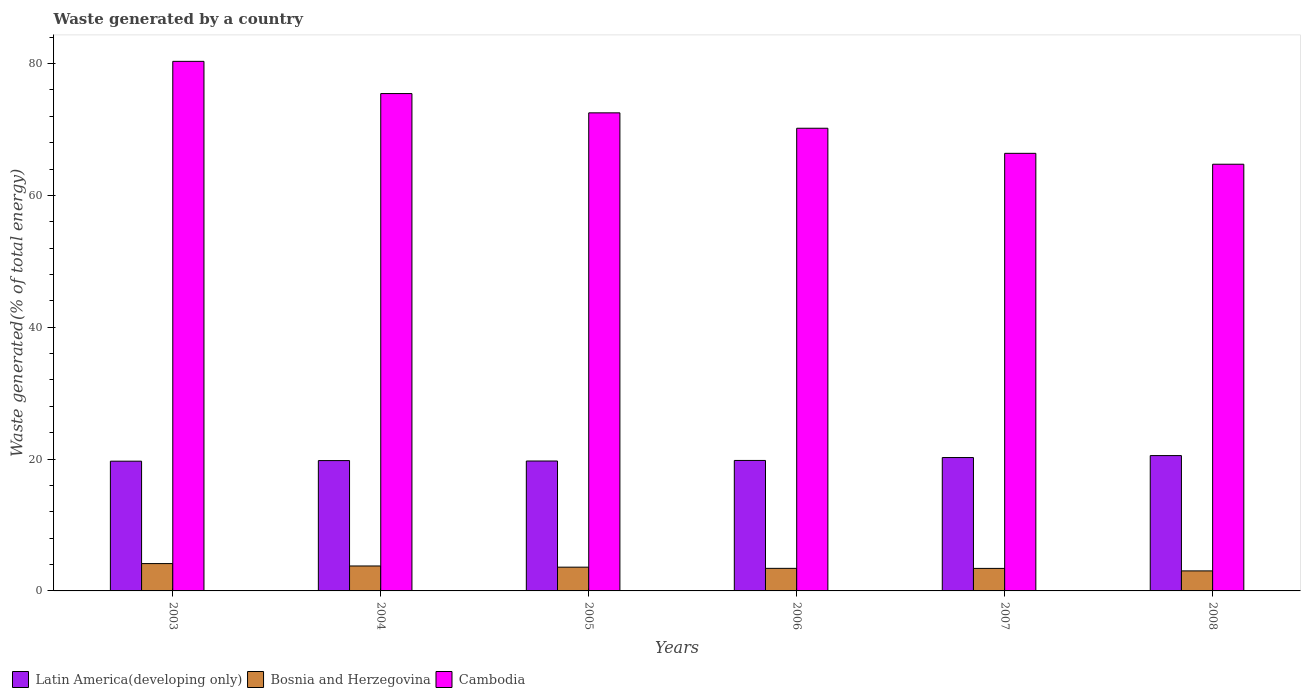How many different coloured bars are there?
Your response must be concise. 3. How many groups of bars are there?
Ensure brevity in your answer.  6. How many bars are there on the 6th tick from the left?
Provide a succinct answer. 3. How many bars are there on the 2nd tick from the right?
Your answer should be compact. 3. In how many cases, is the number of bars for a given year not equal to the number of legend labels?
Keep it short and to the point. 0. What is the total waste generated in Cambodia in 2007?
Offer a terse response. 66.38. Across all years, what is the maximum total waste generated in Cambodia?
Your response must be concise. 80.34. Across all years, what is the minimum total waste generated in Bosnia and Herzegovina?
Make the answer very short. 3.04. In which year was the total waste generated in Latin America(developing only) minimum?
Ensure brevity in your answer.  2003. What is the total total waste generated in Cambodia in the graph?
Your answer should be very brief. 429.62. What is the difference between the total waste generated in Bosnia and Herzegovina in 2004 and that in 2005?
Keep it short and to the point. 0.18. What is the difference between the total waste generated in Latin America(developing only) in 2005 and the total waste generated in Bosnia and Herzegovina in 2003?
Make the answer very short. 15.56. What is the average total waste generated in Cambodia per year?
Your answer should be compact. 71.6. In the year 2004, what is the difference between the total waste generated in Bosnia and Herzegovina and total waste generated in Cambodia?
Offer a very short reply. -71.67. What is the ratio of the total waste generated in Latin America(developing only) in 2004 to that in 2005?
Ensure brevity in your answer.  1. What is the difference between the highest and the second highest total waste generated in Bosnia and Herzegovina?
Offer a very short reply. 0.36. What is the difference between the highest and the lowest total waste generated in Bosnia and Herzegovina?
Give a very brief answer. 1.11. In how many years, is the total waste generated in Bosnia and Herzegovina greater than the average total waste generated in Bosnia and Herzegovina taken over all years?
Make the answer very short. 3. Is the sum of the total waste generated in Cambodia in 2007 and 2008 greater than the maximum total waste generated in Latin America(developing only) across all years?
Ensure brevity in your answer.  Yes. What does the 1st bar from the left in 2007 represents?
Offer a terse response. Latin America(developing only). What does the 1st bar from the right in 2003 represents?
Provide a short and direct response. Cambodia. Are all the bars in the graph horizontal?
Your answer should be compact. No. What is the difference between two consecutive major ticks on the Y-axis?
Provide a succinct answer. 20. Are the values on the major ticks of Y-axis written in scientific E-notation?
Keep it short and to the point. No. How many legend labels are there?
Your answer should be compact. 3. What is the title of the graph?
Provide a succinct answer. Waste generated by a country. What is the label or title of the Y-axis?
Give a very brief answer. Waste generated(% of total energy). What is the Waste generated(% of total energy) of Latin America(developing only) in 2003?
Provide a short and direct response. 19.68. What is the Waste generated(% of total energy) in Bosnia and Herzegovina in 2003?
Provide a short and direct response. 4.15. What is the Waste generated(% of total energy) of Cambodia in 2003?
Make the answer very short. 80.34. What is the Waste generated(% of total energy) of Latin America(developing only) in 2004?
Ensure brevity in your answer.  19.77. What is the Waste generated(% of total energy) in Bosnia and Herzegovina in 2004?
Offer a terse response. 3.79. What is the Waste generated(% of total energy) in Cambodia in 2004?
Ensure brevity in your answer.  75.45. What is the Waste generated(% of total energy) of Latin America(developing only) in 2005?
Offer a very short reply. 19.71. What is the Waste generated(% of total energy) of Bosnia and Herzegovina in 2005?
Provide a short and direct response. 3.61. What is the Waste generated(% of total energy) of Cambodia in 2005?
Provide a succinct answer. 72.53. What is the Waste generated(% of total energy) in Latin America(developing only) in 2006?
Offer a terse response. 19.79. What is the Waste generated(% of total energy) in Bosnia and Herzegovina in 2006?
Provide a succinct answer. 3.42. What is the Waste generated(% of total energy) in Cambodia in 2006?
Give a very brief answer. 70.19. What is the Waste generated(% of total energy) of Latin America(developing only) in 2007?
Your answer should be very brief. 20.23. What is the Waste generated(% of total energy) of Bosnia and Herzegovina in 2007?
Your answer should be compact. 3.42. What is the Waste generated(% of total energy) in Cambodia in 2007?
Your response must be concise. 66.38. What is the Waste generated(% of total energy) in Latin America(developing only) in 2008?
Your answer should be compact. 20.53. What is the Waste generated(% of total energy) in Bosnia and Herzegovina in 2008?
Your answer should be very brief. 3.04. What is the Waste generated(% of total energy) of Cambodia in 2008?
Your answer should be very brief. 64.73. Across all years, what is the maximum Waste generated(% of total energy) in Latin America(developing only)?
Offer a very short reply. 20.53. Across all years, what is the maximum Waste generated(% of total energy) in Bosnia and Herzegovina?
Offer a terse response. 4.15. Across all years, what is the maximum Waste generated(% of total energy) in Cambodia?
Ensure brevity in your answer.  80.34. Across all years, what is the minimum Waste generated(% of total energy) of Latin America(developing only)?
Make the answer very short. 19.68. Across all years, what is the minimum Waste generated(% of total energy) of Bosnia and Herzegovina?
Make the answer very short. 3.04. Across all years, what is the minimum Waste generated(% of total energy) of Cambodia?
Give a very brief answer. 64.73. What is the total Waste generated(% of total energy) of Latin America(developing only) in the graph?
Make the answer very short. 119.72. What is the total Waste generated(% of total energy) in Bosnia and Herzegovina in the graph?
Keep it short and to the point. 21.42. What is the total Waste generated(% of total energy) of Cambodia in the graph?
Keep it short and to the point. 429.62. What is the difference between the Waste generated(% of total energy) in Latin America(developing only) in 2003 and that in 2004?
Make the answer very short. -0.09. What is the difference between the Waste generated(% of total energy) in Bosnia and Herzegovina in 2003 and that in 2004?
Your answer should be compact. 0.36. What is the difference between the Waste generated(% of total energy) of Cambodia in 2003 and that in 2004?
Provide a succinct answer. 4.89. What is the difference between the Waste generated(% of total energy) in Latin America(developing only) in 2003 and that in 2005?
Provide a succinct answer. -0.03. What is the difference between the Waste generated(% of total energy) of Bosnia and Herzegovina in 2003 and that in 2005?
Your answer should be very brief. 0.54. What is the difference between the Waste generated(% of total energy) of Cambodia in 2003 and that in 2005?
Provide a succinct answer. 7.81. What is the difference between the Waste generated(% of total energy) in Latin America(developing only) in 2003 and that in 2006?
Provide a succinct answer. -0.11. What is the difference between the Waste generated(% of total energy) in Bosnia and Herzegovina in 2003 and that in 2006?
Offer a very short reply. 0.72. What is the difference between the Waste generated(% of total energy) of Cambodia in 2003 and that in 2006?
Ensure brevity in your answer.  10.15. What is the difference between the Waste generated(% of total energy) in Latin America(developing only) in 2003 and that in 2007?
Provide a short and direct response. -0.55. What is the difference between the Waste generated(% of total energy) in Bosnia and Herzegovina in 2003 and that in 2007?
Your answer should be very brief. 0.73. What is the difference between the Waste generated(% of total energy) of Cambodia in 2003 and that in 2007?
Provide a succinct answer. 13.95. What is the difference between the Waste generated(% of total energy) in Latin America(developing only) in 2003 and that in 2008?
Offer a very short reply. -0.85. What is the difference between the Waste generated(% of total energy) in Bosnia and Herzegovina in 2003 and that in 2008?
Your answer should be compact. 1.11. What is the difference between the Waste generated(% of total energy) of Cambodia in 2003 and that in 2008?
Ensure brevity in your answer.  15.61. What is the difference between the Waste generated(% of total energy) of Latin America(developing only) in 2004 and that in 2005?
Keep it short and to the point. 0.06. What is the difference between the Waste generated(% of total energy) of Bosnia and Herzegovina in 2004 and that in 2005?
Keep it short and to the point. 0.18. What is the difference between the Waste generated(% of total energy) of Cambodia in 2004 and that in 2005?
Offer a terse response. 2.93. What is the difference between the Waste generated(% of total energy) in Latin America(developing only) in 2004 and that in 2006?
Provide a short and direct response. -0.02. What is the difference between the Waste generated(% of total energy) in Bosnia and Herzegovina in 2004 and that in 2006?
Offer a very short reply. 0.36. What is the difference between the Waste generated(% of total energy) in Cambodia in 2004 and that in 2006?
Your answer should be very brief. 5.26. What is the difference between the Waste generated(% of total energy) in Latin America(developing only) in 2004 and that in 2007?
Make the answer very short. -0.46. What is the difference between the Waste generated(% of total energy) of Bosnia and Herzegovina in 2004 and that in 2007?
Your answer should be compact. 0.37. What is the difference between the Waste generated(% of total energy) of Cambodia in 2004 and that in 2007?
Offer a very short reply. 9.07. What is the difference between the Waste generated(% of total energy) of Latin America(developing only) in 2004 and that in 2008?
Give a very brief answer. -0.76. What is the difference between the Waste generated(% of total energy) of Bosnia and Herzegovina in 2004 and that in 2008?
Provide a short and direct response. 0.75. What is the difference between the Waste generated(% of total energy) of Cambodia in 2004 and that in 2008?
Offer a terse response. 10.72. What is the difference between the Waste generated(% of total energy) in Latin America(developing only) in 2005 and that in 2006?
Your response must be concise. -0.09. What is the difference between the Waste generated(% of total energy) of Bosnia and Herzegovina in 2005 and that in 2006?
Your answer should be very brief. 0.18. What is the difference between the Waste generated(% of total energy) in Cambodia in 2005 and that in 2006?
Give a very brief answer. 2.33. What is the difference between the Waste generated(% of total energy) in Latin America(developing only) in 2005 and that in 2007?
Provide a succinct answer. -0.53. What is the difference between the Waste generated(% of total energy) of Bosnia and Herzegovina in 2005 and that in 2007?
Give a very brief answer. 0.19. What is the difference between the Waste generated(% of total energy) of Cambodia in 2005 and that in 2007?
Your answer should be compact. 6.14. What is the difference between the Waste generated(% of total energy) in Latin America(developing only) in 2005 and that in 2008?
Your response must be concise. -0.82. What is the difference between the Waste generated(% of total energy) of Bosnia and Herzegovina in 2005 and that in 2008?
Your response must be concise. 0.57. What is the difference between the Waste generated(% of total energy) of Cambodia in 2005 and that in 2008?
Offer a terse response. 7.79. What is the difference between the Waste generated(% of total energy) of Latin America(developing only) in 2006 and that in 2007?
Your response must be concise. -0.44. What is the difference between the Waste generated(% of total energy) of Bosnia and Herzegovina in 2006 and that in 2007?
Give a very brief answer. 0.01. What is the difference between the Waste generated(% of total energy) in Cambodia in 2006 and that in 2007?
Offer a very short reply. 3.81. What is the difference between the Waste generated(% of total energy) in Latin America(developing only) in 2006 and that in 2008?
Your answer should be very brief. -0.74. What is the difference between the Waste generated(% of total energy) in Bosnia and Herzegovina in 2006 and that in 2008?
Your response must be concise. 0.39. What is the difference between the Waste generated(% of total energy) in Cambodia in 2006 and that in 2008?
Your answer should be compact. 5.46. What is the difference between the Waste generated(% of total energy) in Latin America(developing only) in 2007 and that in 2008?
Offer a terse response. -0.3. What is the difference between the Waste generated(% of total energy) of Bosnia and Herzegovina in 2007 and that in 2008?
Ensure brevity in your answer.  0.38. What is the difference between the Waste generated(% of total energy) in Cambodia in 2007 and that in 2008?
Keep it short and to the point. 1.65. What is the difference between the Waste generated(% of total energy) in Latin America(developing only) in 2003 and the Waste generated(% of total energy) in Bosnia and Herzegovina in 2004?
Your answer should be compact. 15.9. What is the difference between the Waste generated(% of total energy) of Latin America(developing only) in 2003 and the Waste generated(% of total energy) of Cambodia in 2004?
Keep it short and to the point. -55.77. What is the difference between the Waste generated(% of total energy) in Bosnia and Herzegovina in 2003 and the Waste generated(% of total energy) in Cambodia in 2004?
Offer a terse response. -71.3. What is the difference between the Waste generated(% of total energy) of Latin America(developing only) in 2003 and the Waste generated(% of total energy) of Bosnia and Herzegovina in 2005?
Provide a succinct answer. 16.08. What is the difference between the Waste generated(% of total energy) of Latin America(developing only) in 2003 and the Waste generated(% of total energy) of Cambodia in 2005?
Your answer should be compact. -52.84. What is the difference between the Waste generated(% of total energy) of Bosnia and Herzegovina in 2003 and the Waste generated(% of total energy) of Cambodia in 2005?
Make the answer very short. -68.38. What is the difference between the Waste generated(% of total energy) of Latin America(developing only) in 2003 and the Waste generated(% of total energy) of Bosnia and Herzegovina in 2006?
Offer a terse response. 16.26. What is the difference between the Waste generated(% of total energy) in Latin America(developing only) in 2003 and the Waste generated(% of total energy) in Cambodia in 2006?
Offer a terse response. -50.51. What is the difference between the Waste generated(% of total energy) in Bosnia and Herzegovina in 2003 and the Waste generated(% of total energy) in Cambodia in 2006?
Give a very brief answer. -66.04. What is the difference between the Waste generated(% of total energy) of Latin America(developing only) in 2003 and the Waste generated(% of total energy) of Bosnia and Herzegovina in 2007?
Give a very brief answer. 16.27. What is the difference between the Waste generated(% of total energy) in Latin America(developing only) in 2003 and the Waste generated(% of total energy) in Cambodia in 2007?
Your answer should be compact. -46.7. What is the difference between the Waste generated(% of total energy) of Bosnia and Herzegovina in 2003 and the Waste generated(% of total energy) of Cambodia in 2007?
Your answer should be compact. -62.24. What is the difference between the Waste generated(% of total energy) in Latin America(developing only) in 2003 and the Waste generated(% of total energy) in Bosnia and Herzegovina in 2008?
Make the answer very short. 16.64. What is the difference between the Waste generated(% of total energy) of Latin America(developing only) in 2003 and the Waste generated(% of total energy) of Cambodia in 2008?
Your answer should be very brief. -45.05. What is the difference between the Waste generated(% of total energy) in Bosnia and Herzegovina in 2003 and the Waste generated(% of total energy) in Cambodia in 2008?
Provide a succinct answer. -60.58. What is the difference between the Waste generated(% of total energy) of Latin America(developing only) in 2004 and the Waste generated(% of total energy) of Bosnia and Herzegovina in 2005?
Provide a short and direct response. 16.17. What is the difference between the Waste generated(% of total energy) of Latin America(developing only) in 2004 and the Waste generated(% of total energy) of Cambodia in 2005?
Your answer should be compact. -52.75. What is the difference between the Waste generated(% of total energy) in Bosnia and Herzegovina in 2004 and the Waste generated(% of total energy) in Cambodia in 2005?
Offer a terse response. -68.74. What is the difference between the Waste generated(% of total energy) in Latin America(developing only) in 2004 and the Waste generated(% of total energy) in Bosnia and Herzegovina in 2006?
Provide a succinct answer. 16.35. What is the difference between the Waste generated(% of total energy) of Latin America(developing only) in 2004 and the Waste generated(% of total energy) of Cambodia in 2006?
Provide a succinct answer. -50.42. What is the difference between the Waste generated(% of total energy) in Bosnia and Herzegovina in 2004 and the Waste generated(% of total energy) in Cambodia in 2006?
Offer a very short reply. -66.41. What is the difference between the Waste generated(% of total energy) in Latin America(developing only) in 2004 and the Waste generated(% of total energy) in Bosnia and Herzegovina in 2007?
Offer a terse response. 16.36. What is the difference between the Waste generated(% of total energy) of Latin America(developing only) in 2004 and the Waste generated(% of total energy) of Cambodia in 2007?
Your response must be concise. -46.61. What is the difference between the Waste generated(% of total energy) in Bosnia and Herzegovina in 2004 and the Waste generated(% of total energy) in Cambodia in 2007?
Provide a succinct answer. -62.6. What is the difference between the Waste generated(% of total energy) of Latin America(developing only) in 2004 and the Waste generated(% of total energy) of Bosnia and Herzegovina in 2008?
Your answer should be compact. 16.73. What is the difference between the Waste generated(% of total energy) in Latin America(developing only) in 2004 and the Waste generated(% of total energy) in Cambodia in 2008?
Your answer should be compact. -44.96. What is the difference between the Waste generated(% of total energy) in Bosnia and Herzegovina in 2004 and the Waste generated(% of total energy) in Cambodia in 2008?
Make the answer very short. -60.95. What is the difference between the Waste generated(% of total energy) of Latin America(developing only) in 2005 and the Waste generated(% of total energy) of Bosnia and Herzegovina in 2006?
Offer a very short reply. 16.28. What is the difference between the Waste generated(% of total energy) of Latin America(developing only) in 2005 and the Waste generated(% of total energy) of Cambodia in 2006?
Offer a terse response. -50.48. What is the difference between the Waste generated(% of total energy) in Bosnia and Herzegovina in 2005 and the Waste generated(% of total energy) in Cambodia in 2006?
Your answer should be compact. -66.59. What is the difference between the Waste generated(% of total energy) of Latin America(developing only) in 2005 and the Waste generated(% of total energy) of Bosnia and Herzegovina in 2007?
Keep it short and to the point. 16.29. What is the difference between the Waste generated(% of total energy) of Latin America(developing only) in 2005 and the Waste generated(% of total energy) of Cambodia in 2007?
Make the answer very short. -46.68. What is the difference between the Waste generated(% of total energy) of Bosnia and Herzegovina in 2005 and the Waste generated(% of total energy) of Cambodia in 2007?
Your answer should be compact. -62.78. What is the difference between the Waste generated(% of total energy) in Latin America(developing only) in 2005 and the Waste generated(% of total energy) in Bosnia and Herzegovina in 2008?
Provide a succinct answer. 16.67. What is the difference between the Waste generated(% of total energy) of Latin America(developing only) in 2005 and the Waste generated(% of total energy) of Cambodia in 2008?
Offer a very short reply. -45.02. What is the difference between the Waste generated(% of total energy) in Bosnia and Herzegovina in 2005 and the Waste generated(% of total energy) in Cambodia in 2008?
Offer a terse response. -61.13. What is the difference between the Waste generated(% of total energy) of Latin America(developing only) in 2006 and the Waste generated(% of total energy) of Bosnia and Herzegovina in 2007?
Provide a succinct answer. 16.38. What is the difference between the Waste generated(% of total energy) of Latin America(developing only) in 2006 and the Waste generated(% of total energy) of Cambodia in 2007?
Your answer should be very brief. -46.59. What is the difference between the Waste generated(% of total energy) of Bosnia and Herzegovina in 2006 and the Waste generated(% of total energy) of Cambodia in 2007?
Make the answer very short. -62.96. What is the difference between the Waste generated(% of total energy) of Latin America(developing only) in 2006 and the Waste generated(% of total energy) of Bosnia and Herzegovina in 2008?
Give a very brief answer. 16.76. What is the difference between the Waste generated(% of total energy) of Latin America(developing only) in 2006 and the Waste generated(% of total energy) of Cambodia in 2008?
Offer a terse response. -44.94. What is the difference between the Waste generated(% of total energy) in Bosnia and Herzegovina in 2006 and the Waste generated(% of total energy) in Cambodia in 2008?
Provide a succinct answer. -61.31. What is the difference between the Waste generated(% of total energy) in Latin America(developing only) in 2007 and the Waste generated(% of total energy) in Bosnia and Herzegovina in 2008?
Your answer should be very brief. 17.2. What is the difference between the Waste generated(% of total energy) of Latin America(developing only) in 2007 and the Waste generated(% of total energy) of Cambodia in 2008?
Your answer should be very brief. -44.5. What is the difference between the Waste generated(% of total energy) of Bosnia and Herzegovina in 2007 and the Waste generated(% of total energy) of Cambodia in 2008?
Your answer should be very brief. -61.32. What is the average Waste generated(% of total energy) in Latin America(developing only) per year?
Give a very brief answer. 19.95. What is the average Waste generated(% of total energy) of Bosnia and Herzegovina per year?
Your response must be concise. 3.57. What is the average Waste generated(% of total energy) of Cambodia per year?
Give a very brief answer. 71.6. In the year 2003, what is the difference between the Waste generated(% of total energy) in Latin America(developing only) and Waste generated(% of total energy) in Bosnia and Herzegovina?
Keep it short and to the point. 15.53. In the year 2003, what is the difference between the Waste generated(% of total energy) of Latin America(developing only) and Waste generated(% of total energy) of Cambodia?
Give a very brief answer. -60.66. In the year 2003, what is the difference between the Waste generated(% of total energy) in Bosnia and Herzegovina and Waste generated(% of total energy) in Cambodia?
Make the answer very short. -76.19. In the year 2004, what is the difference between the Waste generated(% of total energy) of Latin America(developing only) and Waste generated(% of total energy) of Bosnia and Herzegovina?
Make the answer very short. 15.99. In the year 2004, what is the difference between the Waste generated(% of total energy) of Latin America(developing only) and Waste generated(% of total energy) of Cambodia?
Provide a short and direct response. -55.68. In the year 2004, what is the difference between the Waste generated(% of total energy) of Bosnia and Herzegovina and Waste generated(% of total energy) of Cambodia?
Provide a succinct answer. -71.67. In the year 2005, what is the difference between the Waste generated(% of total energy) in Latin America(developing only) and Waste generated(% of total energy) in Bosnia and Herzegovina?
Your response must be concise. 16.1. In the year 2005, what is the difference between the Waste generated(% of total energy) of Latin America(developing only) and Waste generated(% of total energy) of Cambodia?
Offer a very short reply. -52.82. In the year 2005, what is the difference between the Waste generated(% of total energy) of Bosnia and Herzegovina and Waste generated(% of total energy) of Cambodia?
Offer a terse response. -68.92. In the year 2006, what is the difference between the Waste generated(% of total energy) of Latin America(developing only) and Waste generated(% of total energy) of Bosnia and Herzegovina?
Your answer should be compact. 16.37. In the year 2006, what is the difference between the Waste generated(% of total energy) of Latin America(developing only) and Waste generated(% of total energy) of Cambodia?
Keep it short and to the point. -50.4. In the year 2006, what is the difference between the Waste generated(% of total energy) in Bosnia and Herzegovina and Waste generated(% of total energy) in Cambodia?
Offer a very short reply. -66.77. In the year 2007, what is the difference between the Waste generated(% of total energy) in Latin America(developing only) and Waste generated(% of total energy) in Bosnia and Herzegovina?
Your answer should be very brief. 16.82. In the year 2007, what is the difference between the Waste generated(% of total energy) of Latin America(developing only) and Waste generated(% of total energy) of Cambodia?
Ensure brevity in your answer.  -46.15. In the year 2007, what is the difference between the Waste generated(% of total energy) of Bosnia and Herzegovina and Waste generated(% of total energy) of Cambodia?
Offer a very short reply. -62.97. In the year 2008, what is the difference between the Waste generated(% of total energy) of Latin America(developing only) and Waste generated(% of total energy) of Bosnia and Herzegovina?
Provide a succinct answer. 17.49. In the year 2008, what is the difference between the Waste generated(% of total energy) in Latin America(developing only) and Waste generated(% of total energy) in Cambodia?
Ensure brevity in your answer.  -44.2. In the year 2008, what is the difference between the Waste generated(% of total energy) in Bosnia and Herzegovina and Waste generated(% of total energy) in Cambodia?
Provide a short and direct response. -61.69. What is the ratio of the Waste generated(% of total energy) of Latin America(developing only) in 2003 to that in 2004?
Offer a very short reply. 1. What is the ratio of the Waste generated(% of total energy) in Bosnia and Herzegovina in 2003 to that in 2004?
Your response must be concise. 1.1. What is the ratio of the Waste generated(% of total energy) of Cambodia in 2003 to that in 2004?
Offer a very short reply. 1.06. What is the ratio of the Waste generated(% of total energy) of Latin America(developing only) in 2003 to that in 2005?
Ensure brevity in your answer.  1. What is the ratio of the Waste generated(% of total energy) in Bosnia and Herzegovina in 2003 to that in 2005?
Give a very brief answer. 1.15. What is the ratio of the Waste generated(% of total energy) of Cambodia in 2003 to that in 2005?
Your response must be concise. 1.11. What is the ratio of the Waste generated(% of total energy) in Bosnia and Herzegovina in 2003 to that in 2006?
Your answer should be compact. 1.21. What is the ratio of the Waste generated(% of total energy) in Cambodia in 2003 to that in 2006?
Provide a short and direct response. 1.14. What is the ratio of the Waste generated(% of total energy) of Latin America(developing only) in 2003 to that in 2007?
Keep it short and to the point. 0.97. What is the ratio of the Waste generated(% of total energy) in Bosnia and Herzegovina in 2003 to that in 2007?
Provide a succinct answer. 1.21. What is the ratio of the Waste generated(% of total energy) of Cambodia in 2003 to that in 2007?
Your answer should be compact. 1.21. What is the ratio of the Waste generated(% of total energy) in Latin America(developing only) in 2003 to that in 2008?
Give a very brief answer. 0.96. What is the ratio of the Waste generated(% of total energy) in Bosnia and Herzegovina in 2003 to that in 2008?
Offer a very short reply. 1.37. What is the ratio of the Waste generated(% of total energy) of Cambodia in 2003 to that in 2008?
Offer a terse response. 1.24. What is the ratio of the Waste generated(% of total energy) in Bosnia and Herzegovina in 2004 to that in 2005?
Provide a short and direct response. 1.05. What is the ratio of the Waste generated(% of total energy) of Cambodia in 2004 to that in 2005?
Provide a succinct answer. 1.04. What is the ratio of the Waste generated(% of total energy) in Bosnia and Herzegovina in 2004 to that in 2006?
Give a very brief answer. 1.11. What is the ratio of the Waste generated(% of total energy) in Cambodia in 2004 to that in 2006?
Offer a terse response. 1.07. What is the ratio of the Waste generated(% of total energy) of Latin America(developing only) in 2004 to that in 2007?
Keep it short and to the point. 0.98. What is the ratio of the Waste generated(% of total energy) of Bosnia and Herzegovina in 2004 to that in 2007?
Your answer should be compact. 1.11. What is the ratio of the Waste generated(% of total energy) of Cambodia in 2004 to that in 2007?
Ensure brevity in your answer.  1.14. What is the ratio of the Waste generated(% of total energy) in Latin America(developing only) in 2004 to that in 2008?
Your answer should be very brief. 0.96. What is the ratio of the Waste generated(% of total energy) of Bosnia and Herzegovina in 2004 to that in 2008?
Offer a terse response. 1.25. What is the ratio of the Waste generated(% of total energy) in Cambodia in 2004 to that in 2008?
Make the answer very short. 1.17. What is the ratio of the Waste generated(% of total energy) of Bosnia and Herzegovina in 2005 to that in 2006?
Offer a very short reply. 1.05. What is the ratio of the Waste generated(% of total energy) of Latin America(developing only) in 2005 to that in 2007?
Make the answer very short. 0.97. What is the ratio of the Waste generated(% of total energy) in Bosnia and Herzegovina in 2005 to that in 2007?
Your answer should be compact. 1.06. What is the ratio of the Waste generated(% of total energy) of Cambodia in 2005 to that in 2007?
Provide a succinct answer. 1.09. What is the ratio of the Waste generated(% of total energy) in Latin America(developing only) in 2005 to that in 2008?
Give a very brief answer. 0.96. What is the ratio of the Waste generated(% of total energy) in Bosnia and Herzegovina in 2005 to that in 2008?
Provide a succinct answer. 1.19. What is the ratio of the Waste generated(% of total energy) in Cambodia in 2005 to that in 2008?
Give a very brief answer. 1.12. What is the ratio of the Waste generated(% of total energy) in Latin America(developing only) in 2006 to that in 2007?
Offer a very short reply. 0.98. What is the ratio of the Waste generated(% of total energy) in Bosnia and Herzegovina in 2006 to that in 2007?
Offer a very short reply. 1. What is the ratio of the Waste generated(% of total energy) in Cambodia in 2006 to that in 2007?
Your answer should be very brief. 1.06. What is the ratio of the Waste generated(% of total energy) of Latin America(developing only) in 2006 to that in 2008?
Your answer should be very brief. 0.96. What is the ratio of the Waste generated(% of total energy) in Bosnia and Herzegovina in 2006 to that in 2008?
Keep it short and to the point. 1.13. What is the ratio of the Waste generated(% of total energy) of Cambodia in 2006 to that in 2008?
Ensure brevity in your answer.  1.08. What is the ratio of the Waste generated(% of total energy) in Latin America(developing only) in 2007 to that in 2008?
Provide a succinct answer. 0.99. What is the ratio of the Waste generated(% of total energy) in Bosnia and Herzegovina in 2007 to that in 2008?
Provide a short and direct response. 1.12. What is the ratio of the Waste generated(% of total energy) in Cambodia in 2007 to that in 2008?
Your answer should be very brief. 1.03. What is the difference between the highest and the second highest Waste generated(% of total energy) in Latin America(developing only)?
Give a very brief answer. 0.3. What is the difference between the highest and the second highest Waste generated(% of total energy) in Bosnia and Herzegovina?
Keep it short and to the point. 0.36. What is the difference between the highest and the second highest Waste generated(% of total energy) of Cambodia?
Your response must be concise. 4.89. What is the difference between the highest and the lowest Waste generated(% of total energy) in Latin America(developing only)?
Your response must be concise. 0.85. What is the difference between the highest and the lowest Waste generated(% of total energy) of Bosnia and Herzegovina?
Provide a succinct answer. 1.11. What is the difference between the highest and the lowest Waste generated(% of total energy) of Cambodia?
Make the answer very short. 15.61. 